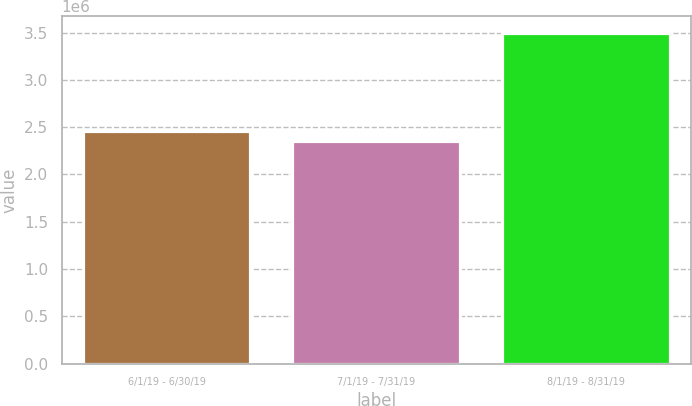Convert chart to OTSL. <chart><loc_0><loc_0><loc_500><loc_500><bar_chart><fcel>6/1/19 - 6/30/19<fcel>7/1/19 - 7/31/19<fcel>8/1/19 - 8/31/19<nl><fcel>2.46348e+06<fcel>2.34849e+06<fcel>3.4984e+06<nl></chart> 